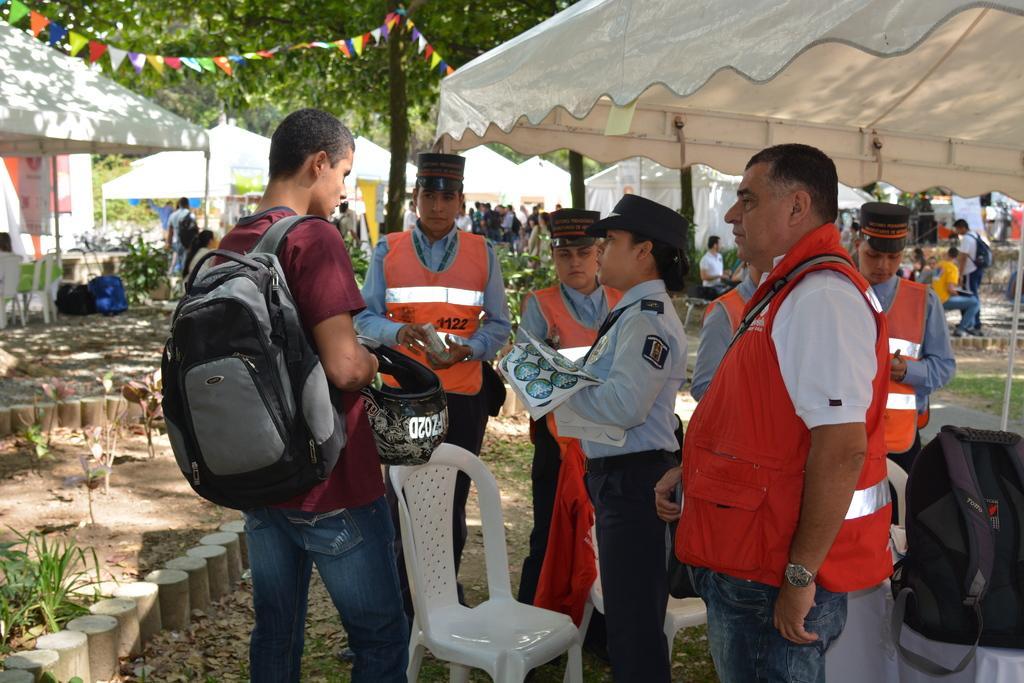How would you summarize this image in a sentence or two? In this picture we can see a group of people standing and talking and in front of them we can see chair, bag, helmet in this person's hand and in background we can see tent, decorative flags, trees, some more persons, path. 